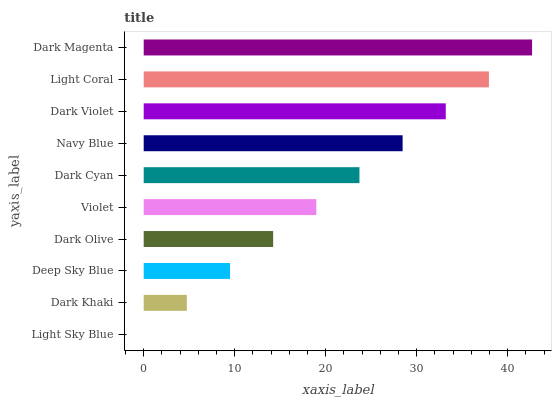Is Light Sky Blue the minimum?
Answer yes or no. Yes. Is Dark Magenta the maximum?
Answer yes or no. Yes. Is Dark Khaki the minimum?
Answer yes or no. No. Is Dark Khaki the maximum?
Answer yes or no. No. Is Dark Khaki greater than Light Sky Blue?
Answer yes or no. Yes. Is Light Sky Blue less than Dark Khaki?
Answer yes or no. Yes. Is Light Sky Blue greater than Dark Khaki?
Answer yes or no. No. Is Dark Khaki less than Light Sky Blue?
Answer yes or no. No. Is Dark Cyan the high median?
Answer yes or no. Yes. Is Violet the low median?
Answer yes or no. Yes. Is Light Coral the high median?
Answer yes or no. No. Is Dark Magenta the low median?
Answer yes or no. No. 